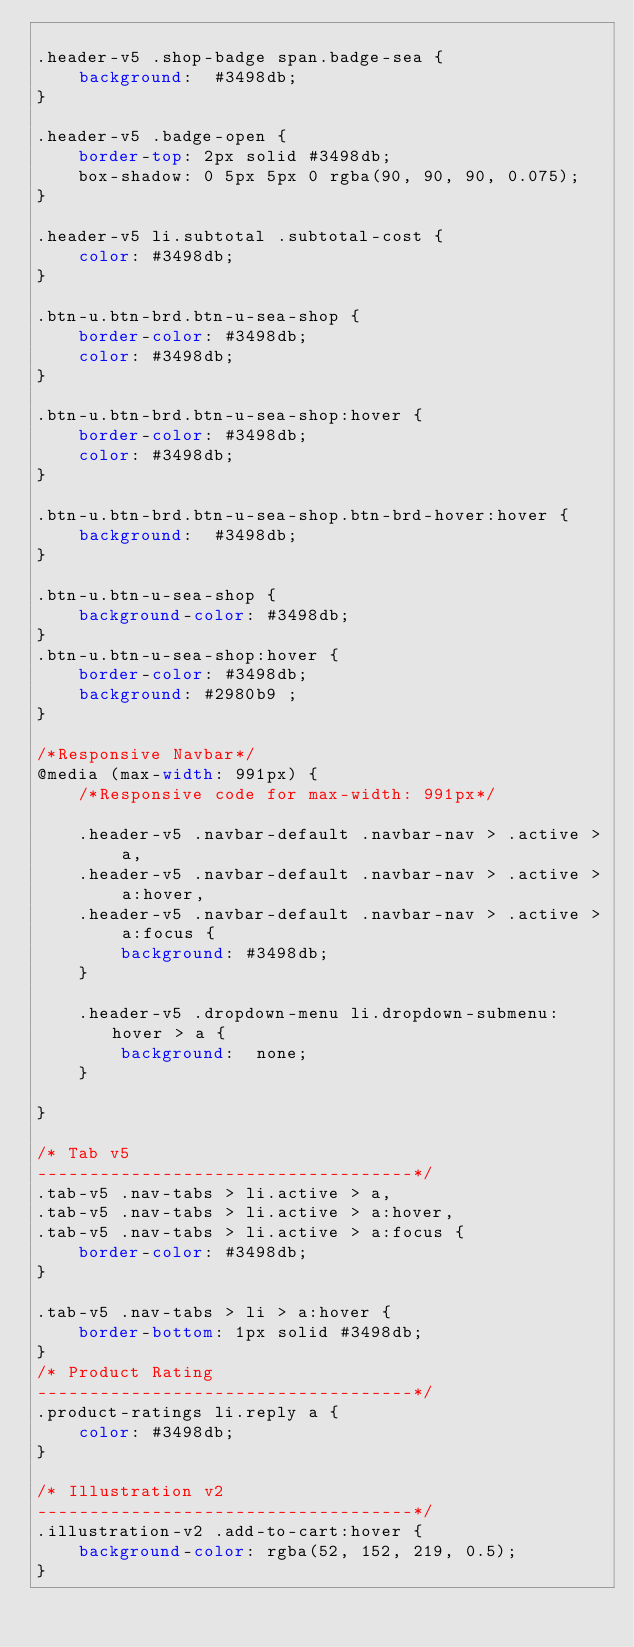<code> <loc_0><loc_0><loc_500><loc_500><_CSS_>
.header-v5 .shop-badge span.badge-sea {
    background:  #3498db;
}

.header-v5 .badge-open {
    border-top: 2px solid #3498db;
    box-shadow: 0 5px 5px 0 rgba(90, 90, 90, 0.075);
}

.header-v5 li.subtotal .subtotal-cost {
    color: #3498db;
}

.btn-u.btn-brd.btn-u-sea-shop {
    border-color: #3498db;
    color: #3498db;
}

.btn-u.btn-brd.btn-u-sea-shop:hover {
    border-color: #3498db;
    color: #3498db;
}

.btn-u.btn-brd.btn-u-sea-shop.btn-brd-hover:hover {
    background:  #3498db;
}

.btn-u.btn-u-sea-shop {
	background-color: #3498db;
}
.btn-u.btn-u-sea-shop:hover {
    border-color: #3498db;
    background: #2980b9	;
}

/*Responsive Navbar*/
@media (max-width: 991px) {
    /*Responsive code for max-width: 991px*/
    
    .header-v5 .navbar-default .navbar-nav > .active > a,
    .header-v5 .navbar-default .navbar-nav > .active > a:hover,
    .header-v5 .navbar-default .navbar-nav > .active > a:focus {
        background: #3498db;
    }

    .header-v5 .dropdown-menu li.dropdown-submenu:hover > a {
        background:  none;
    }

}

/* Tab v5
------------------------------------*/
.tab-v5 .nav-tabs > li.active > a,
.tab-v5 .nav-tabs > li.active > a:hover,
.tab-v5 .nav-tabs > li.active > a:focus {
    border-color: #3498db;
}

.tab-v5 .nav-tabs > li > a:hover {
    border-bottom: 1px solid #3498db;
}
/* Product Rating
------------------------------------*/
.product-ratings li.reply a {
    color: #3498db;
}

/* Illustration v2
------------------------------------*/
.illustration-v2 .add-to-cart:hover {
    background-color: rgba(52, 152, 219, 0.5);
}
</code> 